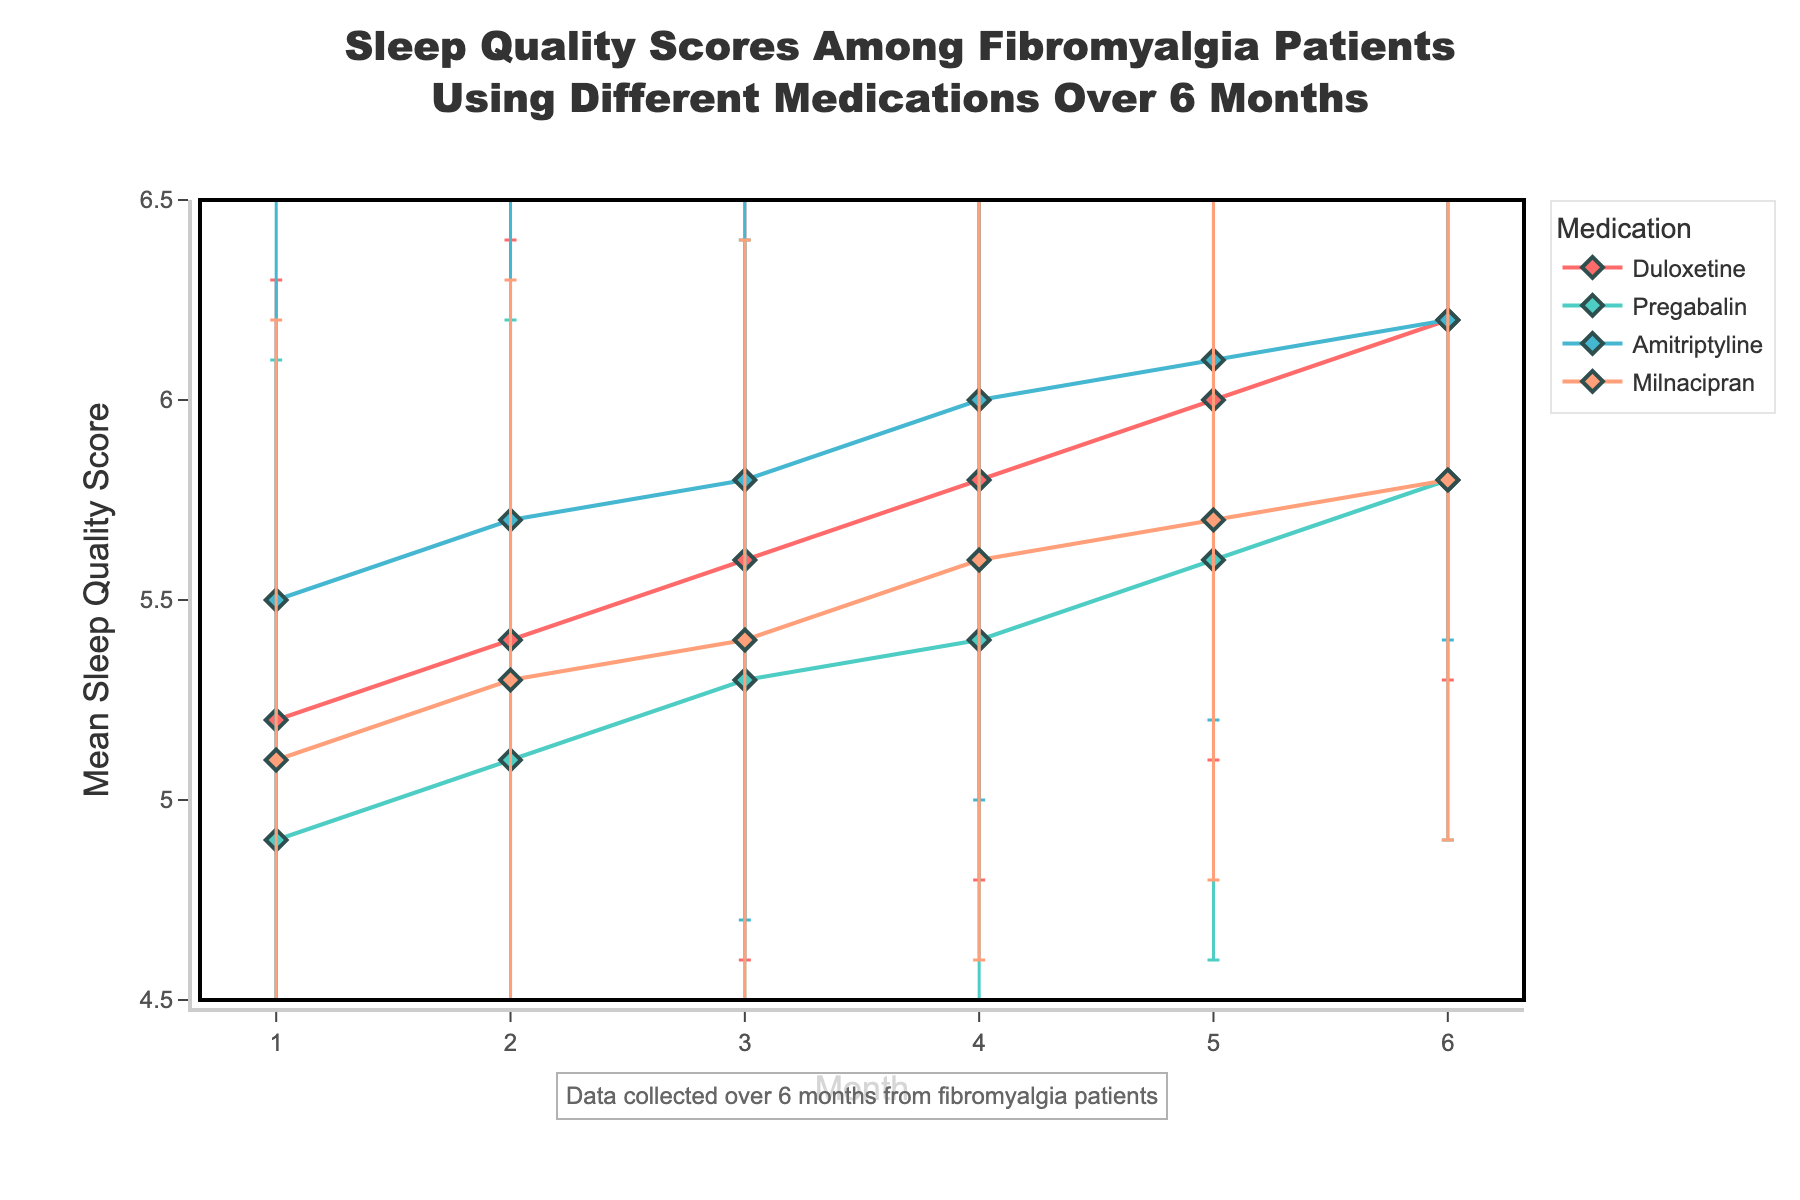What is the title of the line plot? The title of the line plot is usually displayed at the top center of the figure. Here it is: "Sleep Quality Scores Among Fibromyalgia Patients Using Different Medications Over 6 Months".
Answer: Sleep Quality Scores Among Fibromyalgia Patients Using Different Medications Over 6 Months How many medications are compared in the plot? The legend shows the names of the medications being compared. It lists Duloxetine, Pregabalin, Amitriptyline, and Milnacipran.
Answer: 4 What is the range of the y-axis? The y-axis range is typically displayed at the sides of the plot. Here, it goes from 4.5 to 6.5.
Answer: 4.5 to 6.5 Which medication shows the highest mean sleep quality score at month 6? Looking at the line plot at month 6 (the last data point), the highest value on the y-axis is approximately 6.2 for both Duloxetine and Amitriptyline. Since they have the same score, mention both.
Answer: Duloxetine and Amitriptyline What is the mean sleep quality score for Duloxetine at month 3? By looking at the Duloxetine line at month 3 on the x-axis, the score can be inferred in relation to the y-axis. For Duloxetine at month 3, the score is 5.6.
Answer: 5.6 Which medication shows the most improvement in sleep quality from month 1 to month 6? To determine improvement, calculate the difference between month 1 and month 6 scores for each medication and compare them. (Duloxetine: 6.2 - 5.2 = 1.0, Pregabalin: 5.8 - 4.9 = 0.9, Amitriptyline: 6.2 - 5.5 = 0.7, Milnacipran: 5.8 - 5.1 = 0.7). Duloxetine shows the most improvement.
Answer: Duloxetine What is the standard deviation of sleep quality scores for Pregabalin at month 5? The error bars represent the standard deviation. By locating the data point for Pregabalin at month 5, the standard deviation of 1.0 is indicated in the dataset.
Answer: 1.0 How do the sleep quality scores for Amitriptyline change over the 6 months? To see the changes, look at the data points for Amitriptyline on the plot. Scores increase month-by-month: 5.5, 5.7, 5.8, 6.0, 6.1, 6.2. So, there is a consistent increase.
Answer: Increasing Which two medications show the closest mean sleep quality score at month 2? At month 2, compare the scores of all medications and find the closest ones:
Duloxetine: 5.4, Pregabalin: 5.1, Amitriptyline: 5.7, and Milnacipran: 5.3. Duloxetine and Milnacipran are closest with a difference of 0.1 (5.4 - 5.3).
Answer: Duloxetine and Milnacipran 